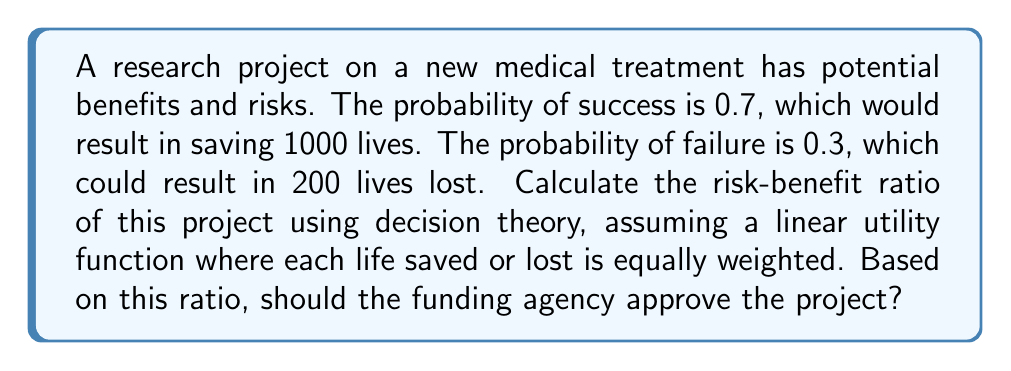Can you solve this math problem? To calculate the risk-benefit ratio using decision theory, we need to:

1. Calculate the expected value (EV) of benefits:
   $$EV_{benefits} = 0.7 \times 1000 = 700$$

2. Calculate the expected value of risks:
   $$EV_{risks} = 0.3 \times 200 = 60$$

3. Calculate the net expected value:
   $$EV_{net} = EV_{benefits} - EV_{risks} = 700 - 60 = 640$$

4. Calculate the risk-benefit ratio:
   $$\text{Risk-Benefit Ratio} = \frac{EV_{risks}}{EV_{benefits}} = \frac{60}{700} = \frac{3}{35} \approx 0.0857$$

The risk-benefit ratio is approximately 0.0857, which means the expected risks are about 8.57% of the expected benefits.

To decide whether to approve the project, we compare the net expected value to zero:

If $EV_{net} > 0$, the project should be approved.
If $EV_{net} < 0$, the project should not be approved.

In this case, $EV_{net} = 640 > 0$, so the project should be approved based on this analysis.
Answer: Risk-Benefit Ratio: $\frac{3}{35} \approx 0.0857$; Approve project 